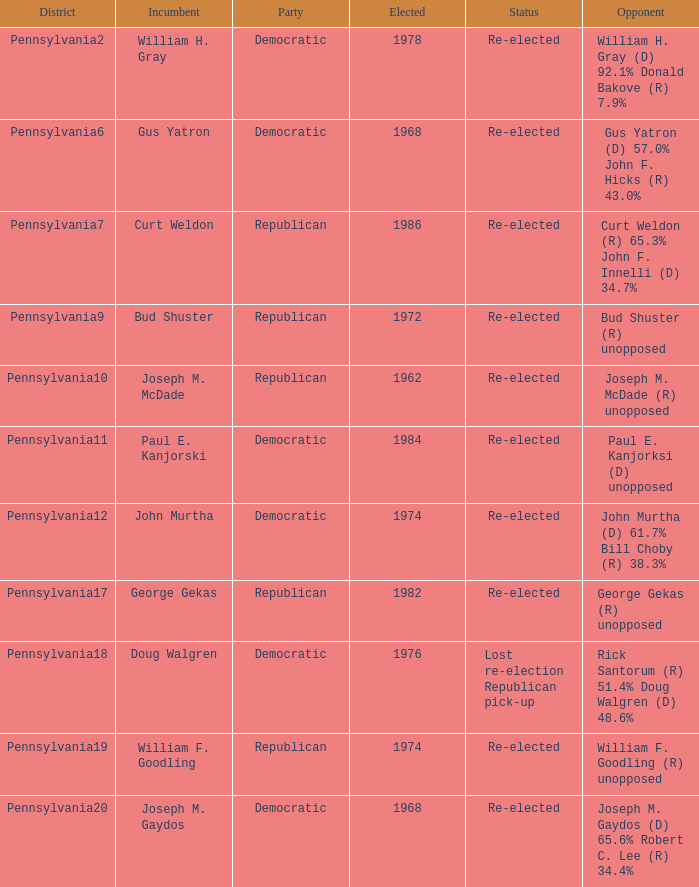Can you list the districts where curt weldon is the incumbent? Pennsylvania7. 